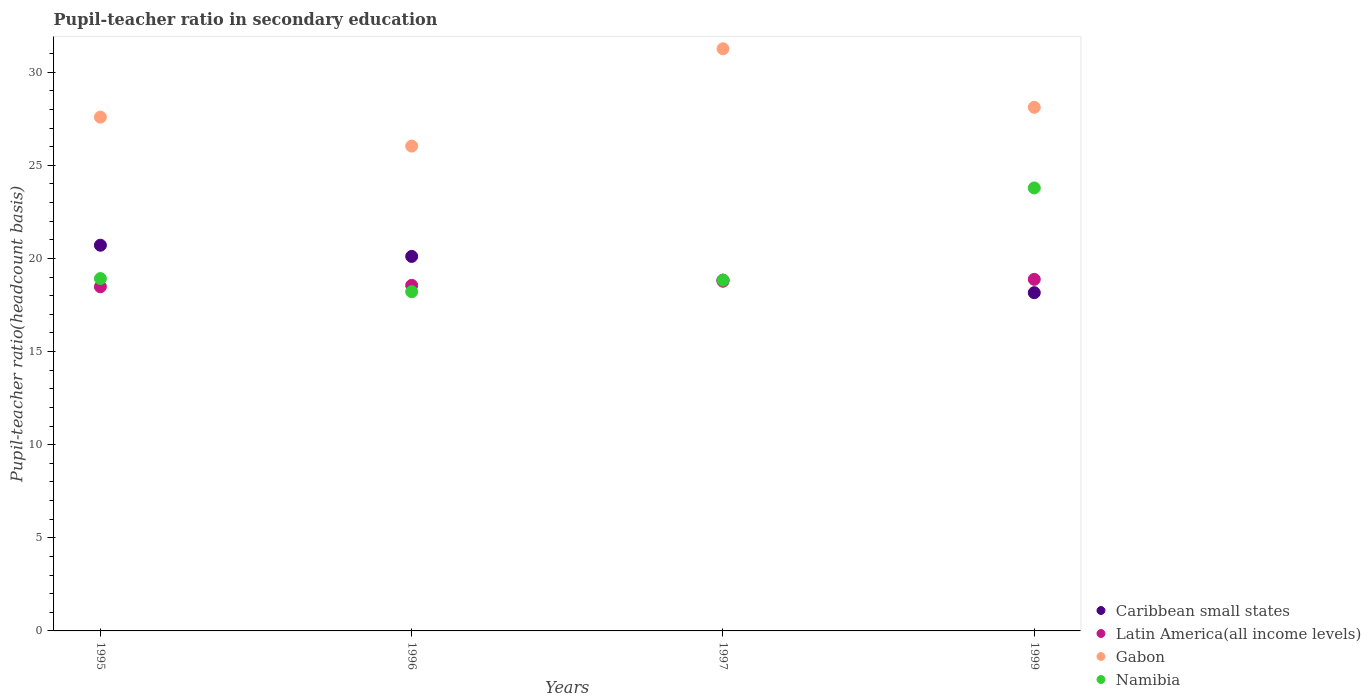What is the pupil-teacher ratio in secondary education in Caribbean small states in 1999?
Your response must be concise. 18.16. Across all years, what is the maximum pupil-teacher ratio in secondary education in Gabon?
Provide a short and direct response. 31.26. Across all years, what is the minimum pupil-teacher ratio in secondary education in Caribbean small states?
Keep it short and to the point. 18.16. In which year was the pupil-teacher ratio in secondary education in Caribbean small states minimum?
Offer a terse response. 1999. What is the total pupil-teacher ratio in secondary education in Caribbean small states in the graph?
Give a very brief answer. 77.82. What is the difference between the pupil-teacher ratio in secondary education in Latin America(all income levels) in 1995 and that in 1996?
Offer a very short reply. -0.07. What is the difference between the pupil-teacher ratio in secondary education in Caribbean small states in 1999 and the pupil-teacher ratio in secondary education in Gabon in 1996?
Offer a very short reply. -7.87. What is the average pupil-teacher ratio in secondary education in Gabon per year?
Offer a very short reply. 28.25. In the year 1997, what is the difference between the pupil-teacher ratio in secondary education in Namibia and pupil-teacher ratio in secondary education in Caribbean small states?
Provide a short and direct response. -0. What is the ratio of the pupil-teacher ratio in secondary education in Gabon in 1997 to that in 1999?
Your response must be concise. 1.11. What is the difference between the highest and the second highest pupil-teacher ratio in secondary education in Caribbean small states?
Provide a short and direct response. 0.6. What is the difference between the highest and the lowest pupil-teacher ratio in secondary education in Namibia?
Your response must be concise. 5.57. Does the pupil-teacher ratio in secondary education in Latin America(all income levels) monotonically increase over the years?
Keep it short and to the point. Yes. Is the pupil-teacher ratio in secondary education in Latin America(all income levels) strictly greater than the pupil-teacher ratio in secondary education in Gabon over the years?
Provide a short and direct response. No. How many dotlines are there?
Provide a short and direct response. 4. What is the difference between two consecutive major ticks on the Y-axis?
Your answer should be very brief. 5. Does the graph contain any zero values?
Ensure brevity in your answer.  No. Where does the legend appear in the graph?
Make the answer very short. Bottom right. How many legend labels are there?
Give a very brief answer. 4. How are the legend labels stacked?
Offer a very short reply. Vertical. What is the title of the graph?
Offer a very short reply. Pupil-teacher ratio in secondary education. Does "Fragile and conflict affected situations" appear as one of the legend labels in the graph?
Your response must be concise. No. What is the label or title of the Y-axis?
Offer a very short reply. Pupil-teacher ratio(headcount basis). What is the Pupil-teacher ratio(headcount basis) of Caribbean small states in 1995?
Ensure brevity in your answer.  20.71. What is the Pupil-teacher ratio(headcount basis) of Latin America(all income levels) in 1995?
Offer a very short reply. 18.48. What is the Pupil-teacher ratio(headcount basis) of Gabon in 1995?
Keep it short and to the point. 27.59. What is the Pupil-teacher ratio(headcount basis) in Namibia in 1995?
Your response must be concise. 18.92. What is the Pupil-teacher ratio(headcount basis) of Caribbean small states in 1996?
Provide a succinct answer. 20.11. What is the Pupil-teacher ratio(headcount basis) of Latin America(all income levels) in 1996?
Offer a very short reply. 18.56. What is the Pupil-teacher ratio(headcount basis) in Gabon in 1996?
Provide a short and direct response. 26.03. What is the Pupil-teacher ratio(headcount basis) in Namibia in 1996?
Your answer should be compact. 18.22. What is the Pupil-teacher ratio(headcount basis) in Caribbean small states in 1997?
Provide a short and direct response. 18.84. What is the Pupil-teacher ratio(headcount basis) in Latin America(all income levels) in 1997?
Ensure brevity in your answer.  18.78. What is the Pupil-teacher ratio(headcount basis) in Gabon in 1997?
Your answer should be compact. 31.26. What is the Pupil-teacher ratio(headcount basis) in Namibia in 1997?
Ensure brevity in your answer.  18.83. What is the Pupil-teacher ratio(headcount basis) of Caribbean small states in 1999?
Keep it short and to the point. 18.16. What is the Pupil-teacher ratio(headcount basis) of Latin America(all income levels) in 1999?
Ensure brevity in your answer.  18.88. What is the Pupil-teacher ratio(headcount basis) of Gabon in 1999?
Keep it short and to the point. 28.12. What is the Pupil-teacher ratio(headcount basis) in Namibia in 1999?
Provide a succinct answer. 23.79. Across all years, what is the maximum Pupil-teacher ratio(headcount basis) in Caribbean small states?
Ensure brevity in your answer.  20.71. Across all years, what is the maximum Pupil-teacher ratio(headcount basis) of Latin America(all income levels)?
Your response must be concise. 18.88. Across all years, what is the maximum Pupil-teacher ratio(headcount basis) of Gabon?
Your response must be concise. 31.26. Across all years, what is the maximum Pupil-teacher ratio(headcount basis) in Namibia?
Provide a short and direct response. 23.79. Across all years, what is the minimum Pupil-teacher ratio(headcount basis) of Caribbean small states?
Your response must be concise. 18.16. Across all years, what is the minimum Pupil-teacher ratio(headcount basis) in Latin America(all income levels)?
Offer a very short reply. 18.48. Across all years, what is the minimum Pupil-teacher ratio(headcount basis) in Gabon?
Give a very brief answer. 26.03. Across all years, what is the minimum Pupil-teacher ratio(headcount basis) of Namibia?
Keep it short and to the point. 18.22. What is the total Pupil-teacher ratio(headcount basis) in Caribbean small states in the graph?
Keep it short and to the point. 77.82. What is the total Pupil-teacher ratio(headcount basis) of Latin America(all income levels) in the graph?
Ensure brevity in your answer.  74.7. What is the total Pupil-teacher ratio(headcount basis) of Gabon in the graph?
Offer a terse response. 113. What is the total Pupil-teacher ratio(headcount basis) of Namibia in the graph?
Your answer should be very brief. 79.76. What is the difference between the Pupil-teacher ratio(headcount basis) in Caribbean small states in 1995 and that in 1996?
Your answer should be very brief. 0.6. What is the difference between the Pupil-teacher ratio(headcount basis) in Latin America(all income levels) in 1995 and that in 1996?
Make the answer very short. -0.07. What is the difference between the Pupil-teacher ratio(headcount basis) in Gabon in 1995 and that in 1996?
Your response must be concise. 1.55. What is the difference between the Pupil-teacher ratio(headcount basis) of Namibia in 1995 and that in 1996?
Give a very brief answer. 0.71. What is the difference between the Pupil-teacher ratio(headcount basis) of Caribbean small states in 1995 and that in 1997?
Provide a succinct answer. 1.88. What is the difference between the Pupil-teacher ratio(headcount basis) in Latin America(all income levels) in 1995 and that in 1997?
Keep it short and to the point. -0.3. What is the difference between the Pupil-teacher ratio(headcount basis) in Gabon in 1995 and that in 1997?
Offer a terse response. -3.67. What is the difference between the Pupil-teacher ratio(headcount basis) in Namibia in 1995 and that in 1997?
Offer a terse response. 0.09. What is the difference between the Pupil-teacher ratio(headcount basis) of Caribbean small states in 1995 and that in 1999?
Make the answer very short. 2.55. What is the difference between the Pupil-teacher ratio(headcount basis) of Latin America(all income levels) in 1995 and that in 1999?
Offer a very short reply. -0.4. What is the difference between the Pupil-teacher ratio(headcount basis) of Gabon in 1995 and that in 1999?
Your response must be concise. -0.53. What is the difference between the Pupil-teacher ratio(headcount basis) in Namibia in 1995 and that in 1999?
Provide a succinct answer. -4.87. What is the difference between the Pupil-teacher ratio(headcount basis) of Caribbean small states in 1996 and that in 1997?
Offer a terse response. 1.27. What is the difference between the Pupil-teacher ratio(headcount basis) in Latin America(all income levels) in 1996 and that in 1997?
Give a very brief answer. -0.22. What is the difference between the Pupil-teacher ratio(headcount basis) in Gabon in 1996 and that in 1997?
Keep it short and to the point. -5.23. What is the difference between the Pupil-teacher ratio(headcount basis) of Namibia in 1996 and that in 1997?
Make the answer very short. -0.62. What is the difference between the Pupil-teacher ratio(headcount basis) in Caribbean small states in 1996 and that in 1999?
Give a very brief answer. 1.95. What is the difference between the Pupil-teacher ratio(headcount basis) in Latin America(all income levels) in 1996 and that in 1999?
Provide a succinct answer. -0.32. What is the difference between the Pupil-teacher ratio(headcount basis) of Gabon in 1996 and that in 1999?
Make the answer very short. -2.08. What is the difference between the Pupil-teacher ratio(headcount basis) of Namibia in 1996 and that in 1999?
Provide a succinct answer. -5.57. What is the difference between the Pupil-teacher ratio(headcount basis) in Caribbean small states in 1997 and that in 1999?
Ensure brevity in your answer.  0.67. What is the difference between the Pupil-teacher ratio(headcount basis) of Latin America(all income levels) in 1997 and that in 1999?
Keep it short and to the point. -0.1. What is the difference between the Pupil-teacher ratio(headcount basis) in Gabon in 1997 and that in 1999?
Provide a short and direct response. 3.14. What is the difference between the Pupil-teacher ratio(headcount basis) in Namibia in 1997 and that in 1999?
Ensure brevity in your answer.  -4.95. What is the difference between the Pupil-teacher ratio(headcount basis) of Caribbean small states in 1995 and the Pupil-teacher ratio(headcount basis) of Latin America(all income levels) in 1996?
Your response must be concise. 2.16. What is the difference between the Pupil-teacher ratio(headcount basis) of Caribbean small states in 1995 and the Pupil-teacher ratio(headcount basis) of Gabon in 1996?
Your answer should be compact. -5.32. What is the difference between the Pupil-teacher ratio(headcount basis) in Caribbean small states in 1995 and the Pupil-teacher ratio(headcount basis) in Namibia in 1996?
Keep it short and to the point. 2.5. What is the difference between the Pupil-teacher ratio(headcount basis) in Latin America(all income levels) in 1995 and the Pupil-teacher ratio(headcount basis) in Gabon in 1996?
Offer a terse response. -7.55. What is the difference between the Pupil-teacher ratio(headcount basis) of Latin America(all income levels) in 1995 and the Pupil-teacher ratio(headcount basis) of Namibia in 1996?
Your response must be concise. 0.27. What is the difference between the Pupil-teacher ratio(headcount basis) in Gabon in 1995 and the Pupil-teacher ratio(headcount basis) in Namibia in 1996?
Your answer should be very brief. 9.37. What is the difference between the Pupil-teacher ratio(headcount basis) in Caribbean small states in 1995 and the Pupil-teacher ratio(headcount basis) in Latin America(all income levels) in 1997?
Make the answer very short. 1.93. What is the difference between the Pupil-teacher ratio(headcount basis) of Caribbean small states in 1995 and the Pupil-teacher ratio(headcount basis) of Gabon in 1997?
Ensure brevity in your answer.  -10.55. What is the difference between the Pupil-teacher ratio(headcount basis) in Caribbean small states in 1995 and the Pupil-teacher ratio(headcount basis) in Namibia in 1997?
Ensure brevity in your answer.  1.88. What is the difference between the Pupil-teacher ratio(headcount basis) in Latin America(all income levels) in 1995 and the Pupil-teacher ratio(headcount basis) in Gabon in 1997?
Give a very brief answer. -12.78. What is the difference between the Pupil-teacher ratio(headcount basis) in Latin America(all income levels) in 1995 and the Pupil-teacher ratio(headcount basis) in Namibia in 1997?
Your answer should be compact. -0.35. What is the difference between the Pupil-teacher ratio(headcount basis) in Gabon in 1995 and the Pupil-teacher ratio(headcount basis) in Namibia in 1997?
Your answer should be very brief. 8.75. What is the difference between the Pupil-teacher ratio(headcount basis) of Caribbean small states in 1995 and the Pupil-teacher ratio(headcount basis) of Latin America(all income levels) in 1999?
Provide a succinct answer. 1.83. What is the difference between the Pupil-teacher ratio(headcount basis) of Caribbean small states in 1995 and the Pupil-teacher ratio(headcount basis) of Gabon in 1999?
Keep it short and to the point. -7.41. What is the difference between the Pupil-teacher ratio(headcount basis) of Caribbean small states in 1995 and the Pupil-teacher ratio(headcount basis) of Namibia in 1999?
Provide a succinct answer. -3.08. What is the difference between the Pupil-teacher ratio(headcount basis) in Latin America(all income levels) in 1995 and the Pupil-teacher ratio(headcount basis) in Gabon in 1999?
Keep it short and to the point. -9.63. What is the difference between the Pupil-teacher ratio(headcount basis) in Latin America(all income levels) in 1995 and the Pupil-teacher ratio(headcount basis) in Namibia in 1999?
Your response must be concise. -5.31. What is the difference between the Pupil-teacher ratio(headcount basis) of Gabon in 1995 and the Pupil-teacher ratio(headcount basis) of Namibia in 1999?
Provide a short and direct response. 3.8. What is the difference between the Pupil-teacher ratio(headcount basis) of Caribbean small states in 1996 and the Pupil-teacher ratio(headcount basis) of Latin America(all income levels) in 1997?
Your response must be concise. 1.33. What is the difference between the Pupil-teacher ratio(headcount basis) of Caribbean small states in 1996 and the Pupil-teacher ratio(headcount basis) of Gabon in 1997?
Ensure brevity in your answer.  -11.15. What is the difference between the Pupil-teacher ratio(headcount basis) in Caribbean small states in 1996 and the Pupil-teacher ratio(headcount basis) in Namibia in 1997?
Give a very brief answer. 1.28. What is the difference between the Pupil-teacher ratio(headcount basis) in Latin America(all income levels) in 1996 and the Pupil-teacher ratio(headcount basis) in Gabon in 1997?
Offer a terse response. -12.71. What is the difference between the Pupil-teacher ratio(headcount basis) of Latin America(all income levels) in 1996 and the Pupil-teacher ratio(headcount basis) of Namibia in 1997?
Your answer should be very brief. -0.28. What is the difference between the Pupil-teacher ratio(headcount basis) of Gabon in 1996 and the Pupil-teacher ratio(headcount basis) of Namibia in 1997?
Your answer should be compact. 7.2. What is the difference between the Pupil-teacher ratio(headcount basis) of Caribbean small states in 1996 and the Pupil-teacher ratio(headcount basis) of Latin America(all income levels) in 1999?
Your answer should be compact. 1.23. What is the difference between the Pupil-teacher ratio(headcount basis) of Caribbean small states in 1996 and the Pupil-teacher ratio(headcount basis) of Gabon in 1999?
Make the answer very short. -8.01. What is the difference between the Pupil-teacher ratio(headcount basis) of Caribbean small states in 1996 and the Pupil-teacher ratio(headcount basis) of Namibia in 1999?
Provide a succinct answer. -3.68. What is the difference between the Pupil-teacher ratio(headcount basis) of Latin America(all income levels) in 1996 and the Pupil-teacher ratio(headcount basis) of Gabon in 1999?
Your response must be concise. -9.56. What is the difference between the Pupil-teacher ratio(headcount basis) of Latin America(all income levels) in 1996 and the Pupil-teacher ratio(headcount basis) of Namibia in 1999?
Your answer should be very brief. -5.23. What is the difference between the Pupil-teacher ratio(headcount basis) of Gabon in 1996 and the Pupil-teacher ratio(headcount basis) of Namibia in 1999?
Provide a succinct answer. 2.25. What is the difference between the Pupil-teacher ratio(headcount basis) of Caribbean small states in 1997 and the Pupil-teacher ratio(headcount basis) of Latin America(all income levels) in 1999?
Offer a terse response. -0.04. What is the difference between the Pupil-teacher ratio(headcount basis) of Caribbean small states in 1997 and the Pupil-teacher ratio(headcount basis) of Gabon in 1999?
Provide a short and direct response. -9.28. What is the difference between the Pupil-teacher ratio(headcount basis) of Caribbean small states in 1997 and the Pupil-teacher ratio(headcount basis) of Namibia in 1999?
Make the answer very short. -4.95. What is the difference between the Pupil-teacher ratio(headcount basis) of Latin America(all income levels) in 1997 and the Pupil-teacher ratio(headcount basis) of Gabon in 1999?
Keep it short and to the point. -9.34. What is the difference between the Pupil-teacher ratio(headcount basis) in Latin America(all income levels) in 1997 and the Pupil-teacher ratio(headcount basis) in Namibia in 1999?
Keep it short and to the point. -5.01. What is the difference between the Pupil-teacher ratio(headcount basis) in Gabon in 1997 and the Pupil-teacher ratio(headcount basis) in Namibia in 1999?
Your answer should be very brief. 7.47. What is the average Pupil-teacher ratio(headcount basis) of Caribbean small states per year?
Offer a terse response. 19.46. What is the average Pupil-teacher ratio(headcount basis) of Latin America(all income levels) per year?
Give a very brief answer. 18.67. What is the average Pupil-teacher ratio(headcount basis) of Gabon per year?
Keep it short and to the point. 28.25. What is the average Pupil-teacher ratio(headcount basis) of Namibia per year?
Your response must be concise. 19.94. In the year 1995, what is the difference between the Pupil-teacher ratio(headcount basis) of Caribbean small states and Pupil-teacher ratio(headcount basis) of Latin America(all income levels)?
Your answer should be very brief. 2.23. In the year 1995, what is the difference between the Pupil-teacher ratio(headcount basis) of Caribbean small states and Pupil-teacher ratio(headcount basis) of Gabon?
Your answer should be compact. -6.88. In the year 1995, what is the difference between the Pupil-teacher ratio(headcount basis) in Caribbean small states and Pupil-teacher ratio(headcount basis) in Namibia?
Make the answer very short. 1.79. In the year 1995, what is the difference between the Pupil-teacher ratio(headcount basis) in Latin America(all income levels) and Pupil-teacher ratio(headcount basis) in Gabon?
Provide a succinct answer. -9.11. In the year 1995, what is the difference between the Pupil-teacher ratio(headcount basis) of Latin America(all income levels) and Pupil-teacher ratio(headcount basis) of Namibia?
Offer a very short reply. -0.44. In the year 1995, what is the difference between the Pupil-teacher ratio(headcount basis) in Gabon and Pupil-teacher ratio(headcount basis) in Namibia?
Your answer should be very brief. 8.67. In the year 1996, what is the difference between the Pupil-teacher ratio(headcount basis) of Caribbean small states and Pupil-teacher ratio(headcount basis) of Latin America(all income levels)?
Provide a succinct answer. 1.55. In the year 1996, what is the difference between the Pupil-teacher ratio(headcount basis) in Caribbean small states and Pupil-teacher ratio(headcount basis) in Gabon?
Provide a succinct answer. -5.92. In the year 1996, what is the difference between the Pupil-teacher ratio(headcount basis) in Caribbean small states and Pupil-teacher ratio(headcount basis) in Namibia?
Keep it short and to the point. 1.9. In the year 1996, what is the difference between the Pupil-teacher ratio(headcount basis) of Latin America(all income levels) and Pupil-teacher ratio(headcount basis) of Gabon?
Give a very brief answer. -7.48. In the year 1996, what is the difference between the Pupil-teacher ratio(headcount basis) in Latin America(all income levels) and Pupil-teacher ratio(headcount basis) in Namibia?
Keep it short and to the point. 0.34. In the year 1996, what is the difference between the Pupil-teacher ratio(headcount basis) in Gabon and Pupil-teacher ratio(headcount basis) in Namibia?
Make the answer very short. 7.82. In the year 1997, what is the difference between the Pupil-teacher ratio(headcount basis) of Caribbean small states and Pupil-teacher ratio(headcount basis) of Latin America(all income levels)?
Make the answer very short. 0.06. In the year 1997, what is the difference between the Pupil-teacher ratio(headcount basis) in Caribbean small states and Pupil-teacher ratio(headcount basis) in Gabon?
Your answer should be compact. -12.42. In the year 1997, what is the difference between the Pupil-teacher ratio(headcount basis) of Caribbean small states and Pupil-teacher ratio(headcount basis) of Namibia?
Your answer should be compact. 0. In the year 1997, what is the difference between the Pupil-teacher ratio(headcount basis) in Latin America(all income levels) and Pupil-teacher ratio(headcount basis) in Gabon?
Make the answer very short. -12.48. In the year 1997, what is the difference between the Pupil-teacher ratio(headcount basis) of Latin America(all income levels) and Pupil-teacher ratio(headcount basis) of Namibia?
Give a very brief answer. -0.06. In the year 1997, what is the difference between the Pupil-teacher ratio(headcount basis) of Gabon and Pupil-teacher ratio(headcount basis) of Namibia?
Give a very brief answer. 12.43. In the year 1999, what is the difference between the Pupil-teacher ratio(headcount basis) in Caribbean small states and Pupil-teacher ratio(headcount basis) in Latin America(all income levels)?
Your response must be concise. -0.72. In the year 1999, what is the difference between the Pupil-teacher ratio(headcount basis) in Caribbean small states and Pupil-teacher ratio(headcount basis) in Gabon?
Provide a succinct answer. -9.95. In the year 1999, what is the difference between the Pupil-teacher ratio(headcount basis) in Caribbean small states and Pupil-teacher ratio(headcount basis) in Namibia?
Offer a terse response. -5.62. In the year 1999, what is the difference between the Pupil-teacher ratio(headcount basis) in Latin America(all income levels) and Pupil-teacher ratio(headcount basis) in Gabon?
Give a very brief answer. -9.24. In the year 1999, what is the difference between the Pupil-teacher ratio(headcount basis) of Latin America(all income levels) and Pupil-teacher ratio(headcount basis) of Namibia?
Your answer should be compact. -4.91. In the year 1999, what is the difference between the Pupil-teacher ratio(headcount basis) in Gabon and Pupil-teacher ratio(headcount basis) in Namibia?
Provide a succinct answer. 4.33. What is the ratio of the Pupil-teacher ratio(headcount basis) in Caribbean small states in 1995 to that in 1996?
Ensure brevity in your answer.  1.03. What is the ratio of the Pupil-teacher ratio(headcount basis) in Latin America(all income levels) in 1995 to that in 1996?
Make the answer very short. 1. What is the ratio of the Pupil-teacher ratio(headcount basis) in Gabon in 1995 to that in 1996?
Give a very brief answer. 1.06. What is the ratio of the Pupil-teacher ratio(headcount basis) of Namibia in 1995 to that in 1996?
Your response must be concise. 1.04. What is the ratio of the Pupil-teacher ratio(headcount basis) of Caribbean small states in 1995 to that in 1997?
Offer a very short reply. 1.1. What is the ratio of the Pupil-teacher ratio(headcount basis) of Latin America(all income levels) in 1995 to that in 1997?
Ensure brevity in your answer.  0.98. What is the ratio of the Pupil-teacher ratio(headcount basis) in Gabon in 1995 to that in 1997?
Make the answer very short. 0.88. What is the ratio of the Pupil-teacher ratio(headcount basis) of Caribbean small states in 1995 to that in 1999?
Offer a terse response. 1.14. What is the ratio of the Pupil-teacher ratio(headcount basis) in Latin America(all income levels) in 1995 to that in 1999?
Provide a short and direct response. 0.98. What is the ratio of the Pupil-teacher ratio(headcount basis) of Gabon in 1995 to that in 1999?
Make the answer very short. 0.98. What is the ratio of the Pupil-teacher ratio(headcount basis) of Namibia in 1995 to that in 1999?
Your response must be concise. 0.8. What is the ratio of the Pupil-teacher ratio(headcount basis) in Caribbean small states in 1996 to that in 1997?
Make the answer very short. 1.07. What is the ratio of the Pupil-teacher ratio(headcount basis) in Latin America(all income levels) in 1996 to that in 1997?
Provide a succinct answer. 0.99. What is the ratio of the Pupil-teacher ratio(headcount basis) of Gabon in 1996 to that in 1997?
Your response must be concise. 0.83. What is the ratio of the Pupil-teacher ratio(headcount basis) of Namibia in 1996 to that in 1997?
Provide a short and direct response. 0.97. What is the ratio of the Pupil-teacher ratio(headcount basis) in Caribbean small states in 1996 to that in 1999?
Provide a short and direct response. 1.11. What is the ratio of the Pupil-teacher ratio(headcount basis) in Latin America(all income levels) in 1996 to that in 1999?
Your answer should be compact. 0.98. What is the ratio of the Pupil-teacher ratio(headcount basis) in Gabon in 1996 to that in 1999?
Your answer should be very brief. 0.93. What is the ratio of the Pupil-teacher ratio(headcount basis) in Namibia in 1996 to that in 1999?
Offer a very short reply. 0.77. What is the ratio of the Pupil-teacher ratio(headcount basis) in Caribbean small states in 1997 to that in 1999?
Give a very brief answer. 1.04. What is the ratio of the Pupil-teacher ratio(headcount basis) of Gabon in 1997 to that in 1999?
Provide a succinct answer. 1.11. What is the ratio of the Pupil-teacher ratio(headcount basis) in Namibia in 1997 to that in 1999?
Your answer should be very brief. 0.79. What is the difference between the highest and the second highest Pupil-teacher ratio(headcount basis) in Caribbean small states?
Make the answer very short. 0.6. What is the difference between the highest and the second highest Pupil-teacher ratio(headcount basis) in Latin America(all income levels)?
Make the answer very short. 0.1. What is the difference between the highest and the second highest Pupil-teacher ratio(headcount basis) of Gabon?
Your response must be concise. 3.14. What is the difference between the highest and the second highest Pupil-teacher ratio(headcount basis) of Namibia?
Your answer should be very brief. 4.87. What is the difference between the highest and the lowest Pupil-teacher ratio(headcount basis) of Caribbean small states?
Offer a terse response. 2.55. What is the difference between the highest and the lowest Pupil-teacher ratio(headcount basis) of Latin America(all income levels)?
Offer a terse response. 0.4. What is the difference between the highest and the lowest Pupil-teacher ratio(headcount basis) in Gabon?
Your answer should be compact. 5.23. What is the difference between the highest and the lowest Pupil-teacher ratio(headcount basis) of Namibia?
Give a very brief answer. 5.57. 